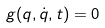<formula> <loc_0><loc_0><loc_500><loc_500>g ( q , \dot { q } , t ) = 0</formula> 